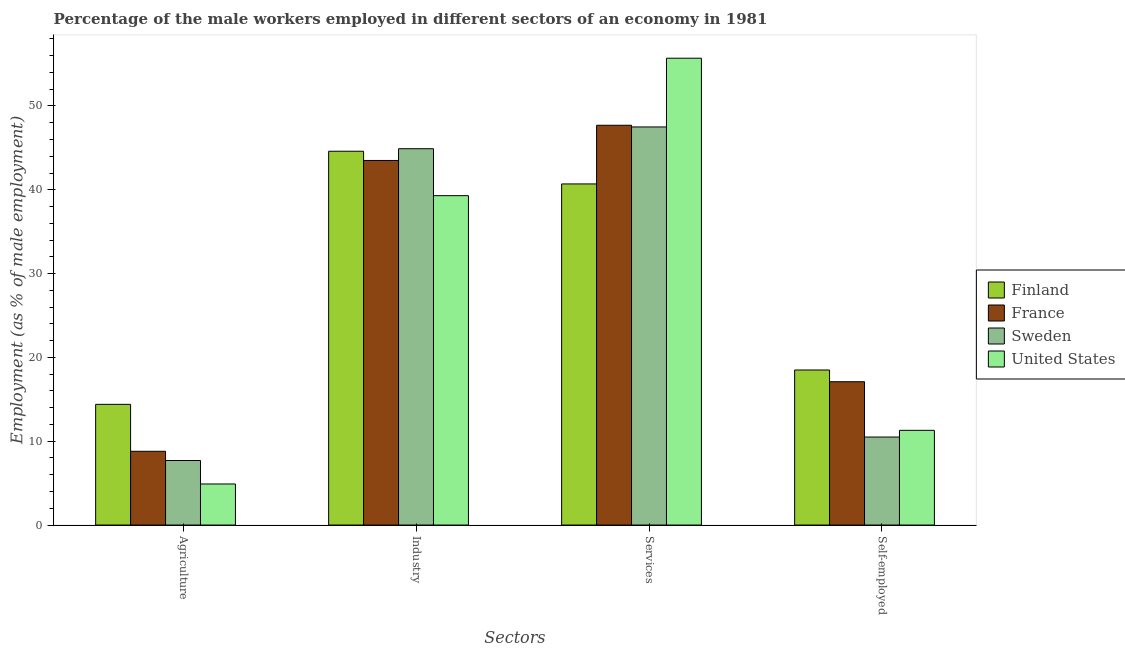How many groups of bars are there?
Your response must be concise. 4. Are the number of bars on each tick of the X-axis equal?
Your answer should be very brief. Yes. How many bars are there on the 2nd tick from the left?
Make the answer very short. 4. How many bars are there on the 2nd tick from the right?
Keep it short and to the point. 4. What is the label of the 1st group of bars from the left?
Ensure brevity in your answer.  Agriculture. What is the percentage of male workers in agriculture in United States?
Your response must be concise. 4.9. Across all countries, what is the maximum percentage of male workers in industry?
Offer a terse response. 44.9. Across all countries, what is the minimum percentage of male workers in services?
Offer a terse response. 40.7. In which country was the percentage of male workers in industry minimum?
Your answer should be compact. United States. What is the total percentage of self employed male workers in the graph?
Your response must be concise. 57.4. What is the difference between the percentage of male workers in agriculture in Finland and that in United States?
Provide a succinct answer. 9.5. What is the difference between the percentage of male workers in agriculture in Finland and the percentage of self employed male workers in Sweden?
Provide a succinct answer. 3.9. What is the average percentage of male workers in agriculture per country?
Offer a very short reply. 8.95. What is the difference between the percentage of male workers in industry and percentage of male workers in services in Sweden?
Make the answer very short. -2.6. In how many countries, is the percentage of self employed male workers greater than 24 %?
Your response must be concise. 0. What is the ratio of the percentage of male workers in agriculture in Finland to that in United States?
Your answer should be very brief. 2.94. What is the difference between the highest and the second highest percentage of male workers in agriculture?
Make the answer very short. 5.6. What is the difference between the highest and the lowest percentage of male workers in industry?
Provide a short and direct response. 5.6. In how many countries, is the percentage of self employed male workers greater than the average percentage of self employed male workers taken over all countries?
Offer a terse response. 2. Is the sum of the percentage of male workers in services in France and Finland greater than the maximum percentage of self employed male workers across all countries?
Provide a succinct answer. Yes. Is it the case that in every country, the sum of the percentage of male workers in agriculture and percentage of male workers in industry is greater than the sum of percentage of male workers in services and percentage of self employed male workers?
Your answer should be very brief. No. What does the 4th bar from the left in Self-employed represents?
Offer a terse response. United States. What does the 1st bar from the right in Agriculture represents?
Keep it short and to the point. United States. Are all the bars in the graph horizontal?
Your answer should be compact. No. How many countries are there in the graph?
Ensure brevity in your answer.  4. Does the graph contain any zero values?
Keep it short and to the point. No. Does the graph contain grids?
Provide a short and direct response. No. Where does the legend appear in the graph?
Your answer should be compact. Center right. How are the legend labels stacked?
Ensure brevity in your answer.  Vertical. What is the title of the graph?
Give a very brief answer. Percentage of the male workers employed in different sectors of an economy in 1981. What is the label or title of the X-axis?
Give a very brief answer. Sectors. What is the label or title of the Y-axis?
Keep it short and to the point. Employment (as % of male employment). What is the Employment (as % of male employment) of Finland in Agriculture?
Ensure brevity in your answer.  14.4. What is the Employment (as % of male employment) of France in Agriculture?
Ensure brevity in your answer.  8.8. What is the Employment (as % of male employment) in Sweden in Agriculture?
Give a very brief answer. 7.7. What is the Employment (as % of male employment) of United States in Agriculture?
Your answer should be compact. 4.9. What is the Employment (as % of male employment) of Finland in Industry?
Your response must be concise. 44.6. What is the Employment (as % of male employment) in France in Industry?
Ensure brevity in your answer.  43.5. What is the Employment (as % of male employment) in Sweden in Industry?
Provide a succinct answer. 44.9. What is the Employment (as % of male employment) in United States in Industry?
Ensure brevity in your answer.  39.3. What is the Employment (as % of male employment) in Finland in Services?
Provide a succinct answer. 40.7. What is the Employment (as % of male employment) of France in Services?
Your answer should be very brief. 47.7. What is the Employment (as % of male employment) of Sweden in Services?
Make the answer very short. 47.5. What is the Employment (as % of male employment) in United States in Services?
Ensure brevity in your answer.  55.7. What is the Employment (as % of male employment) of Finland in Self-employed?
Your answer should be very brief. 18.5. What is the Employment (as % of male employment) in France in Self-employed?
Keep it short and to the point. 17.1. What is the Employment (as % of male employment) of United States in Self-employed?
Make the answer very short. 11.3. Across all Sectors, what is the maximum Employment (as % of male employment) of Finland?
Provide a short and direct response. 44.6. Across all Sectors, what is the maximum Employment (as % of male employment) in France?
Your answer should be compact. 47.7. Across all Sectors, what is the maximum Employment (as % of male employment) of Sweden?
Your answer should be very brief. 47.5. Across all Sectors, what is the maximum Employment (as % of male employment) of United States?
Keep it short and to the point. 55.7. Across all Sectors, what is the minimum Employment (as % of male employment) of Finland?
Your answer should be very brief. 14.4. Across all Sectors, what is the minimum Employment (as % of male employment) in France?
Offer a terse response. 8.8. Across all Sectors, what is the minimum Employment (as % of male employment) of Sweden?
Provide a short and direct response. 7.7. Across all Sectors, what is the minimum Employment (as % of male employment) of United States?
Offer a very short reply. 4.9. What is the total Employment (as % of male employment) of Finland in the graph?
Offer a very short reply. 118.2. What is the total Employment (as % of male employment) of France in the graph?
Your answer should be compact. 117.1. What is the total Employment (as % of male employment) in Sweden in the graph?
Your answer should be compact. 110.6. What is the total Employment (as % of male employment) in United States in the graph?
Keep it short and to the point. 111.2. What is the difference between the Employment (as % of male employment) in Finland in Agriculture and that in Industry?
Provide a short and direct response. -30.2. What is the difference between the Employment (as % of male employment) of France in Agriculture and that in Industry?
Offer a terse response. -34.7. What is the difference between the Employment (as % of male employment) in Sweden in Agriculture and that in Industry?
Make the answer very short. -37.2. What is the difference between the Employment (as % of male employment) of United States in Agriculture and that in Industry?
Offer a terse response. -34.4. What is the difference between the Employment (as % of male employment) in Finland in Agriculture and that in Services?
Make the answer very short. -26.3. What is the difference between the Employment (as % of male employment) of France in Agriculture and that in Services?
Offer a terse response. -38.9. What is the difference between the Employment (as % of male employment) in Sweden in Agriculture and that in Services?
Make the answer very short. -39.8. What is the difference between the Employment (as % of male employment) of United States in Agriculture and that in Services?
Provide a succinct answer. -50.8. What is the difference between the Employment (as % of male employment) in France in Agriculture and that in Self-employed?
Provide a short and direct response. -8.3. What is the difference between the Employment (as % of male employment) in Finland in Industry and that in Services?
Ensure brevity in your answer.  3.9. What is the difference between the Employment (as % of male employment) in France in Industry and that in Services?
Offer a very short reply. -4.2. What is the difference between the Employment (as % of male employment) of Sweden in Industry and that in Services?
Provide a succinct answer. -2.6. What is the difference between the Employment (as % of male employment) in United States in Industry and that in Services?
Offer a terse response. -16.4. What is the difference between the Employment (as % of male employment) of Finland in Industry and that in Self-employed?
Your answer should be very brief. 26.1. What is the difference between the Employment (as % of male employment) of France in Industry and that in Self-employed?
Give a very brief answer. 26.4. What is the difference between the Employment (as % of male employment) of Sweden in Industry and that in Self-employed?
Offer a terse response. 34.4. What is the difference between the Employment (as % of male employment) in France in Services and that in Self-employed?
Offer a terse response. 30.6. What is the difference between the Employment (as % of male employment) of United States in Services and that in Self-employed?
Ensure brevity in your answer.  44.4. What is the difference between the Employment (as % of male employment) in Finland in Agriculture and the Employment (as % of male employment) in France in Industry?
Make the answer very short. -29.1. What is the difference between the Employment (as % of male employment) of Finland in Agriculture and the Employment (as % of male employment) of Sweden in Industry?
Your answer should be compact. -30.5. What is the difference between the Employment (as % of male employment) in Finland in Agriculture and the Employment (as % of male employment) in United States in Industry?
Your answer should be compact. -24.9. What is the difference between the Employment (as % of male employment) in France in Agriculture and the Employment (as % of male employment) in Sweden in Industry?
Offer a terse response. -36.1. What is the difference between the Employment (as % of male employment) of France in Agriculture and the Employment (as % of male employment) of United States in Industry?
Provide a succinct answer. -30.5. What is the difference between the Employment (as % of male employment) of Sweden in Agriculture and the Employment (as % of male employment) of United States in Industry?
Provide a short and direct response. -31.6. What is the difference between the Employment (as % of male employment) in Finland in Agriculture and the Employment (as % of male employment) in France in Services?
Your response must be concise. -33.3. What is the difference between the Employment (as % of male employment) in Finland in Agriculture and the Employment (as % of male employment) in Sweden in Services?
Your answer should be compact. -33.1. What is the difference between the Employment (as % of male employment) in Finland in Agriculture and the Employment (as % of male employment) in United States in Services?
Offer a terse response. -41.3. What is the difference between the Employment (as % of male employment) of France in Agriculture and the Employment (as % of male employment) of Sweden in Services?
Your response must be concise. -38.7. What is the difference between the Employment (as % of male employment) of France in Agriculture and the Employment (as % of male employment) of United States in Services?
Offer a very short reply. -46.9. What is the difference between the Employment (as % of male employment) in Sweden in Agriculture and the Employment (as % of male employment) in United States in Services?
Provide a succinct answer. -48. What is the difference between the Employment (as % of male employment) of Finland in Agriculture and the Employment (as % of male employment) of United States in Self-employed?
Make the answer very short. 3.1. What is the difference between the Employment (as % of male employment) of France in Agriculture and the Employment (as % of male employment) of United States in Self-employed?
Ensure brevity in your answer.  -2.5. What is the difference between the Employment (as % of male employment) in Sweden in Agriculture and the Employment (as % of male employment) in United States in Self-employed?
Your response must be concise. -3.6. What is the difference between the Employment (as % of male employment) in Finland in Industry and the Employment (as % of male employment) in Sweden in Services?
Give a very brief answer. -2.9. What is the difference between the Employment (as % of male employment) of Finland in Industry and the Employment (as % of male employment) of United States in Services?
Your answer should be very brief. -11.1. What is the difference between the Employment (as % of male employment) of France in Industry and the Employment (as % of male employment) of United States in Services?
Your response must be concise. -12.2. What is the difference between the Employment (as % of male employment) in Finland in Industry and the Employment (as % of male employment) in Sweden in Self-employed?
Your answer should be compact. 34.1. What is the difference between the Employment (as % of male employment) of Finland in Industry and the Employment (as % of male employment) of United States in Self-employed?
Keep it short and to the point. 33.3. What is the difference between the Employment (as % of male employment) of France in Industry and the Employment (as % of male employment) of United States in Self-employed?
Provide a short and direct response. 32.2. What is the difference between the Employment (as % of male employment) in Sweden in Industry and the Employment (as % of male employment) in United States in Self-employed?
Offer a very short reply. 33.6. What is the difference between the Employment (as % of male employment) of Finland in Services and the Employment (as % of male employment) of France in Self-employed?
Ensure brevity in your answer.  23.6. What is the difference between the Employment (as % of male employment) of Finland in Services and the Employment (as % of male employment) of Sweden in Self-employed?
Provide a short and direct response. 30.2. What is the difference between the Employment (as % of male employment) of Finland in Services and the Employment (as % of male employment) of United States in Self-employed?
Your response must be concise. 29.4. What is the difference between the Employment (as % of male employment) of France in Services and the Employment (as % of male employment) of Sweden in Self-employed?
Ensure brevity in your answer.  37.2. What is the difference between the Employment (as % of male employment) in France in Services and the Employment (as % of male employment) in United States in Self-employed?
Your answer should be very brief. 36.4. What is the difference between the Employment (as % of male employment) of Sweden in Services and the Employment (as % of male employment) of United States in Self-employed?
Make the answer very short. 36.2. What is the average Employment (as % of male employment) in Finland per Sectors?
Your answer should be very brief. 29.55. What is the average Employment (as % of male employment) of France per Sectors?
Offer a very short reply. 29.27. What is the average Employment (as % of male employment) of Sweden per Sectors?
Your answer should be very brief. 27.65. What is the average Employment (as % of male employment) of United States per Sectors?
Give a very brief answer. 27.8. What is the difference between the Employment (as % of male employment) of Finland and Employment (as % of male employment) of France in Agriculture?
Your response must be concise. 5.6. What is the difference between the Employment (as % of male employment) in Finland and Employment (as % of male employment) in United States in Agriculture?
Offer a very short reply. 9.5. What is the difference between the Employment (as % of male employment) in France and Employment (as % of male employment) in Sweden in Agriculture?
Offer a terse response. 1.1. What is the difference between the Employment (as % of male employment) in Finland and Employment (as % of male employment) in United States in Industry?
Offer a terse response. 5.3. What is the difference between the Employment (as % of male employment) of Sweden and Employment (as % of male employment) of United States in Industry?
Your answer should be compact. 5.6. What is the difference between the Employment (as % of male employment) in France and Employment (as % of male employment) in United States in Services?
Offer a very short reply. -8. What is the difference between the Employment (as % of male employment) in Finland and Employment (as % of male employment) in France in Self-employed?
Your answer should be compact. 1.4. What is the difference between the Employment (as % of male employment) of Finland and Employment (as % of male employment) of Sweden in Self-employed?
Keep it short and to the point. 8. What is the difference between the Employment (as % of male employment) of France and Employment (as % of male employment) of United States in Self-employed?
Keep it short and to the point. 5.8. What is the difference between the Employment (as % of male employment) in Sweden and Employment (as % of male employment) in United States in Self-employed?
Ensure brevity in your answer.  -0.8. What is the ratio of the Employment (as % of male employment) of Finland in Agriculture to that in Industry?
Make the answer very short. 0.32. What is the ratio of the Employment (as % of male employment) of France in Agriculture to that in Industry?
Your answer should be compact. 0.2. What is the ratio of the Employment (as % of male employment) of Sweden in Agriculture to that in Industry?
Your response must be concise. 0.17. What is the ratio of the Employment (as % of male employment) of United States in Agriculture to that in Industry?
Provide a short and direct response. 0.12. What is the ratio of the Employment (as % of male employment) in Finland in Agriculture to that in Services?
Your response must be concise. 0.35. What is the ratio of the Employment (as % of male employment) of France in Agriculture to that in Services?
Offer a very short reply. 0.18. What is the ratio of the Employment (as % of male employment) in Sweden in Agriculture to that in Services?
Make the answer very short. 0.16. What is the ratio of the Employment (as % of male employment) of United States in Agriculture to that in Services?
Keep it short and to the point. 0.09. What is the ratio of the Employment (as % of male employment) of Finland in Agriculture to that in Self-employed?
Your answer should be very brief. 0.78. What is the ratio of the Employment (as % of male employment) in France in Agriculture to that in Self-employed?
Your answer should be compact. 0.51. What is the ratio of the Employment (as % of male employment) of Sweden in Agriculture to that in Self-employed?
Your response must be concise. 0.73. What is the ratio of the Employment (as % of male employment) in United States in Agriculture to that in Self-employed?
Make the answer very short. 0.43. What is the ratio of the Employment (as % of male employment) in Finland in Industry to that in Services?
Your response must be concise. 1.1. What is the ratio of the Employment (as % of male employment) in France in Industry to that in Services?
Give a very brief answer. 0.91. What is the ratio of the Employment (as % of male employment) in Sweden in Industry to that in Services?
Your answer should be compact. 0.95. What is the ratio of the Employment (as % of male employment) in United States in Industry to that in Services?
Offer a very short reply. 0.71. What is the ratio of the Employment (as % of male employment) of Finland in Industry to that in Self-employed?
Provide a short and direct response. 2.41. What is the ratio of the Employment (as % of male employment) of France in Industry to that in Self-employed?
Offer a terse response. 2.54. What is the ratio of the Employment (as % of male employment) of Sweden in Industry to that in Self-employed?
Make the answer very short. 4.28. What is the ratio of the Employment (as % of male employment) in United States in Industry to that in Self-employed?
Your response must be concise. 3.48. What is the ratio of the Employment (as % of male employment) in Finland in Services to that in Self-employed?
Your answer should be compact. 2.2. What is the ratio of the Employment (as % of male employment) in France in Services to that in Self-employed?
Offer a very short reply. 2.79. What is the ratio of the Employment (as % of male employment) in Sweden in Services to that in Self-employed?
Your response must be concise. 4.52. What is the ratio of the Employment (as % of male employment) in United States in Services to that in Self-employed?
Make the answer very short. 4.93. What is the difference between the highest and the second highest Employment (as % of male employment) in Finland?
Offer a very short reply. 3.9. What is the difference between the highest and the second highest Employment (as % of male employment) of Sweden?
Offer a terse response. 2.6. What is the difference between the highest and the lowest Employment (as % of male employment) in Finland?
Provide a short and direct response. 30.2. What is the difference between the highest and the lowest Employment (as % of male employment) of France?
Provide a succinct answer. 38.9. What is the difference between the highest and the lowest Employment (as % of male employment) in Sweden?
Keep it short and to the point. 39.8. What is the difference between the highest and the lowest Employment (as % of male employment) of United States?
Ensure brevity in your answer.  50.8. 